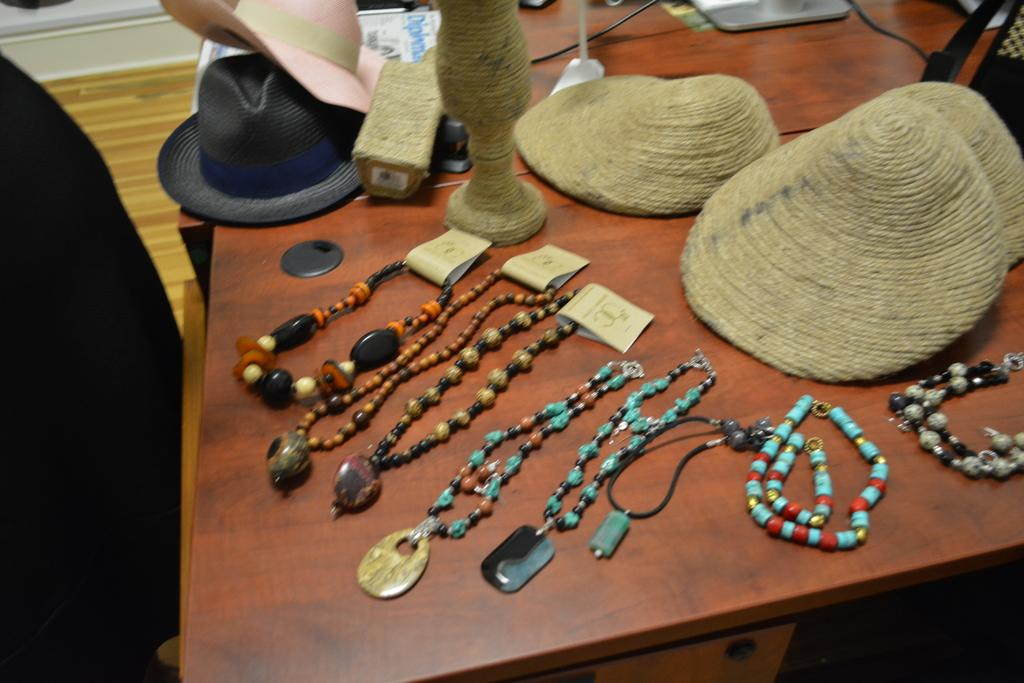What type of accessories are visible in the image? There are hats in the image. What other items can be seen in the image? There are ornaments in the image. What is on the table in the image? There are papers on a table in the image. What type of pet is visible in the image? There is no pet present in the image. What type of oatmeal is being prepared in the image? There is no oatmeal or preparation of food visible in the image. 